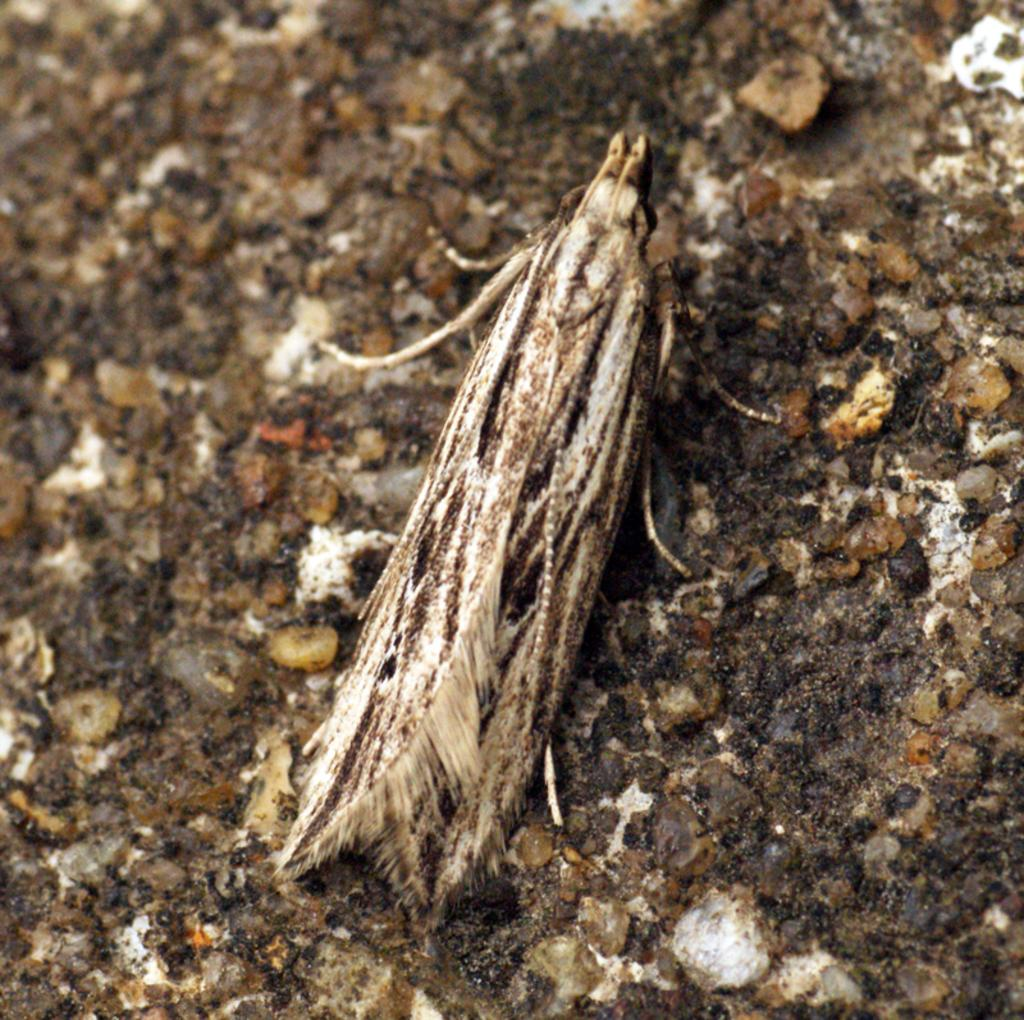What type of creature can be seen in the image? There is an insect in the image. What can be seen in the background of the image? There are small stones in the background of the image. What scent can be detected from the insect in the image? There is no indication of a scent associated with the insect in the image. 